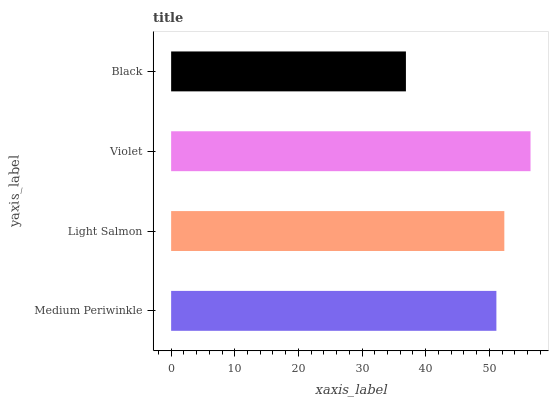Is Black the minimum?
Answer yes or no. Yes. Is Violet the maximum?
Answer yes or no. Yes. Is Light Salmon the minimum?
Answer yes or no. No. Is Light Salmon the maximum?
Answer yes or no. No. Is Light Salmon greater than Medium Periwinkle?
Answer yes or no. Yes. Is Medium Periwinkle less than Light Salmon?
Answer yes or no. Yes. Is Medium Periwinkle greater than Light Salmon?
Answer yes or no. No. Is Light Salmon less than Medium Periwinkle?
Answer yes or no. No. Is Light Salmon the high median?
Answer yes or no. Yes. Is Medium Periwinkle the low median?
Answer yes or no. Yes. Is Medium Periwinkle the high median?
Answer yes or no. No. Is Violet the low median?
Answer yes or no. No. 